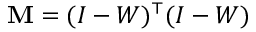<formula> <loc_0><loc_0><loc_500><loc_500>M = ( I - W ) ^ { \top } ( I - W )</formula> 